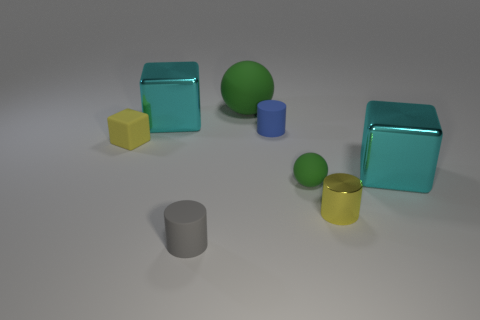Subtract all purple cylinders. How many cyan cubes are left? 2 Add 2 large gray matte things. How many objects exist? 10 Subtract all small blue matte cylinders. How many cylinders are left? 2 Add 1 big green rubber spheres. How many big green rubber spheres are left? 2 Add 5 tiny metal objects. How many tiny metal objects exist? 6 Subtract 0 purple spheres. How many objects are left? 8 Subtract all spheres. How many objects are left? 6 Subtract 1 cylinders. How many cylinders are left? 2 Subtract all gray blocks. Subtract all brown spheres. How many blocks are left? 3 Subtract all tiny yellow matte cubes. Subtract all small blue cylinders. How many objects are left? 6 